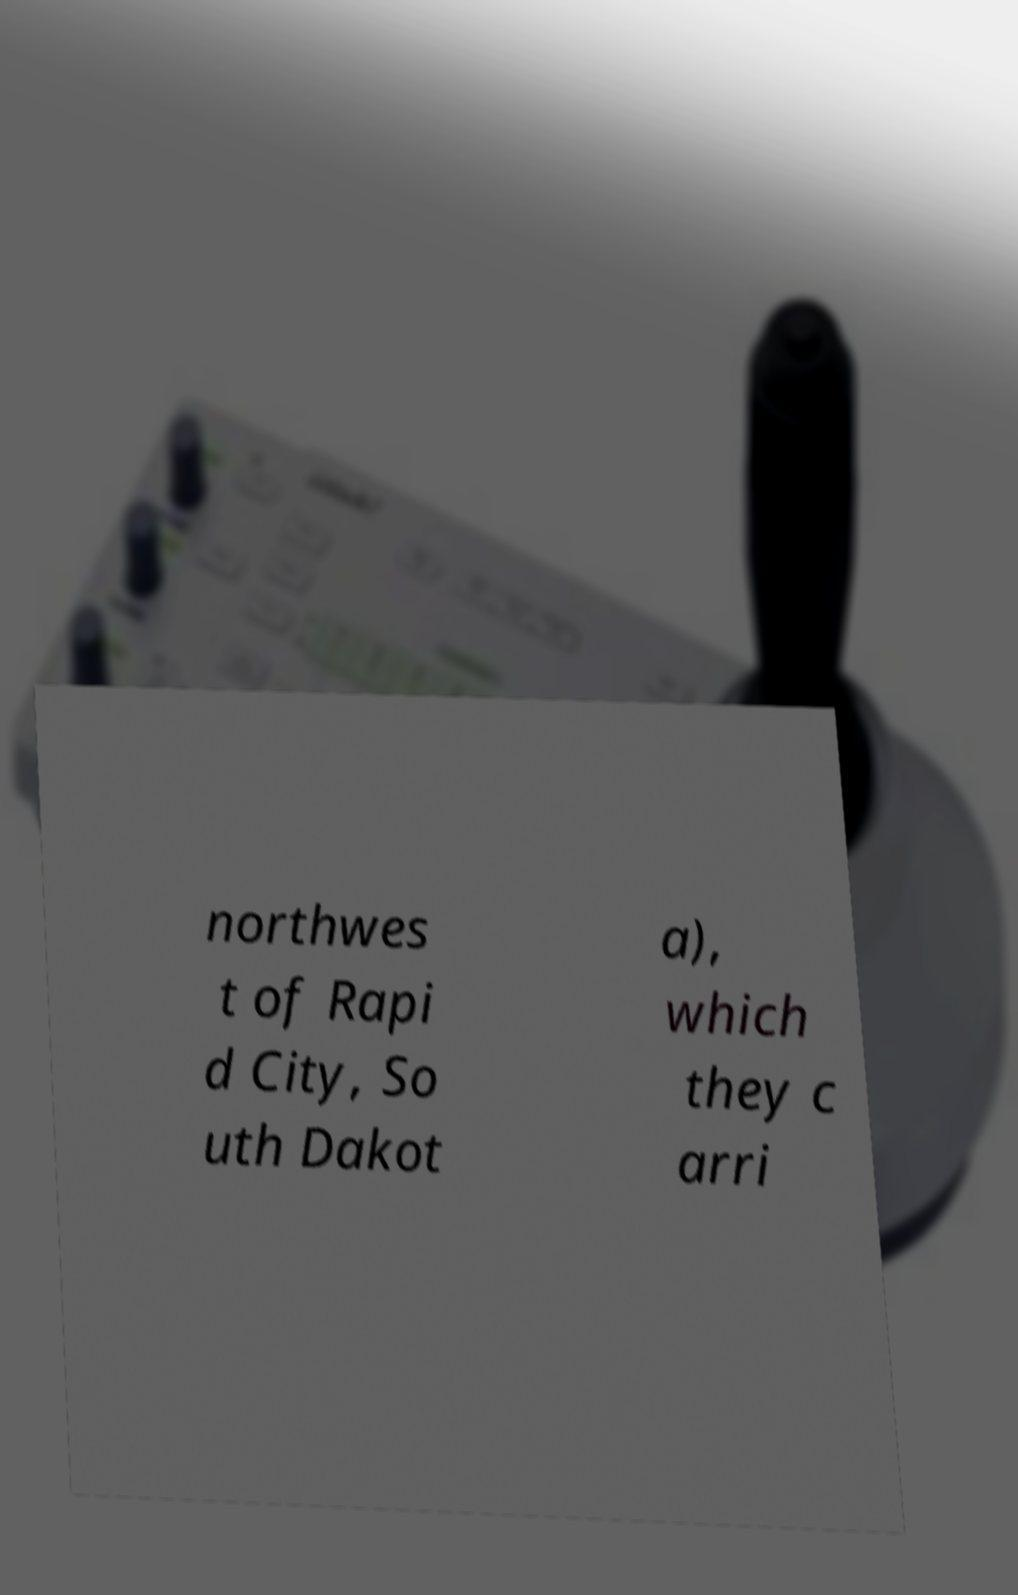Can you accurately transcribe the text from the provided image for me? northwes t of Rapi d City, So uth Dakot a), which they c arri 